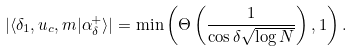<formula> <loc_0><loc_0><loc_500><loc_500>| \langle \delta _ { 1 } , u _ { c } , m | \alpha ^ { + } _ { \delta } \rangle | = \min \left ( \Theta \left ( \frac { 1 } { \cos \delta \sqrt { \log N } } \right ) , 1 \right ) .</formula> 